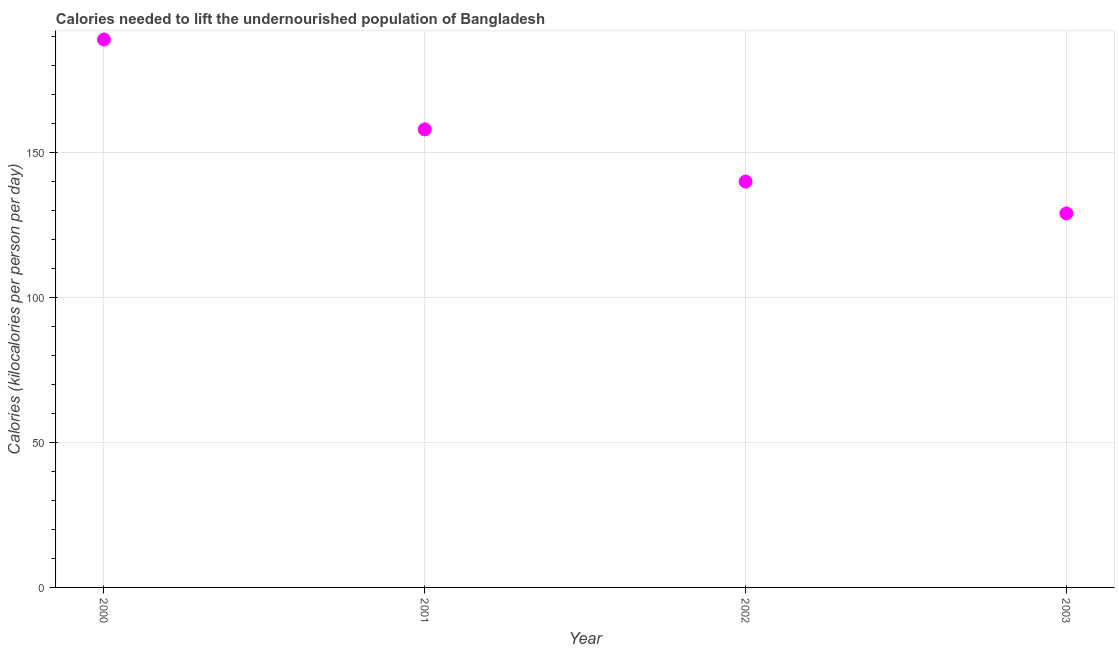What is the depth of food deficit in 2002?
Provide a succinct answer. 140. Across all years, what is the maximum depth of food deficit?
Your response must be concise. 189. Across all years, what is the minimum depth of food deficit?
Make the answer very short. 129. In which year was the depth of food deficit maximum?
Provide a succinct answer. 2000. What is the sum of the depth of food deficit?
Your answer should be very brief. 616. What is the difference between the depth of food deficit in 2001 and 2002?
Your answer should be very brief. 18. What is the average depth of food deficit per year?
Provide a succinct answer. 154. What is the median depth of food deficit?
Your answer should be compact. 149. In how many years, is the depth of food deficit greater than 170 kilocalories?
Your answer should be compact. 1. Do a majority of the years between 2000 and 2002 (inclusive) have depth of food deficit greater than 100 kilocalories?
Keep it short and to the point. Yes. What is the ratio of the depth of food deficit in 2002 to that in 2003?
Keep it short and to the point. 1.09. Is the difference between the depth of food deficit in 2000 and 2002 greater than the difference between any two years?
Make the answer very short. No. What is the difference between the highest and the lowest depth of food deficit?
Give a very brief answer. 60. How many years are there in the graph?
Offer a terse response. 4. Does the graph contain grids?
Keep it short and to the point. Yes. What is the title of the graph?
Make the answer very short. Calories needed to lift the undernourished population of Bangladesh. What is the label or title of the Y-axis?
Provide a succinct answer. Calories (kilocalories per person per day). What is the Calories (kilocalories per person per day) in 2000?
Your answer should be very brief. 189. What is the Calories (kilocalories per person per day) in 2001?
Provide a succinct answer. 158. What is the Calories (kilocalories per person per day) in 2002?
Make the answer very short. 140. What is the Calories (kilocalories per person per day) in 2003?
Provide a succinct answer. 129. What is the difference between the Calories (kilocalories per person per day) in 2000 and 2001?
Offer a very short reply. 31. What is the difference between the Calories (kilocalories per person per day) in 2000 and 2002?
Your response must be concise. 49. What is the difference between the Calories (kilocalories per person per day) in 2001 and 2002?
Make the answer very short. 18. What is the ratio of the Calories (kilocalories per person per day) in 2000 to that in 2001?
Offer a terse response. 1.2. What is the ratio of the Calories (kilocalories per person per day) in 2000 to that in 2002?
Ensure brevity in your answer.  1.35. What is the ratio of the Calories (kilocalories per person per day) in 2000 to that in 2003?
Ensure brevity in your answer.  1.47. What is the ratio of the Calories (kilocalories per person per day) in 2001 to that in 2002?
Provide a succinct answer. 1.13. What is the ratio of the Calories (kilocalories per person per day) in 2001 to that in 2003?
Your response must be concise. 1.23. What is the ratio of the Calories (kilocalories per person per day) in 2002 to that in 2003?
Give a very brief answer. 1.08. 